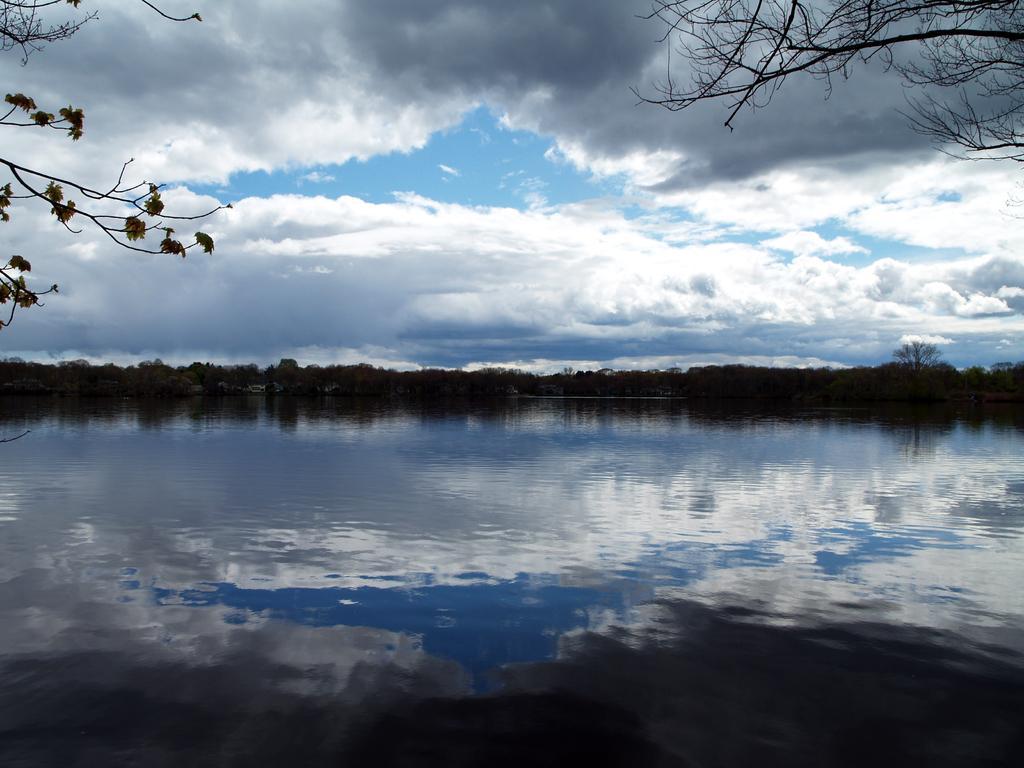In one or two sentences, can you explain what this image depicts? This is an outside view. At the bottom of this image there is a sea. In the background there are many trees. On the top of the image I can see the sky and clouds. 